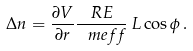Convert formula to latex. <formula><loc_0><loc_0><loc_500><loc_500>\Delta n = \frac { \partial V } { \partial r } \frac { R E } { \ m e f f } \, L \cos \phi \, .</formula> 